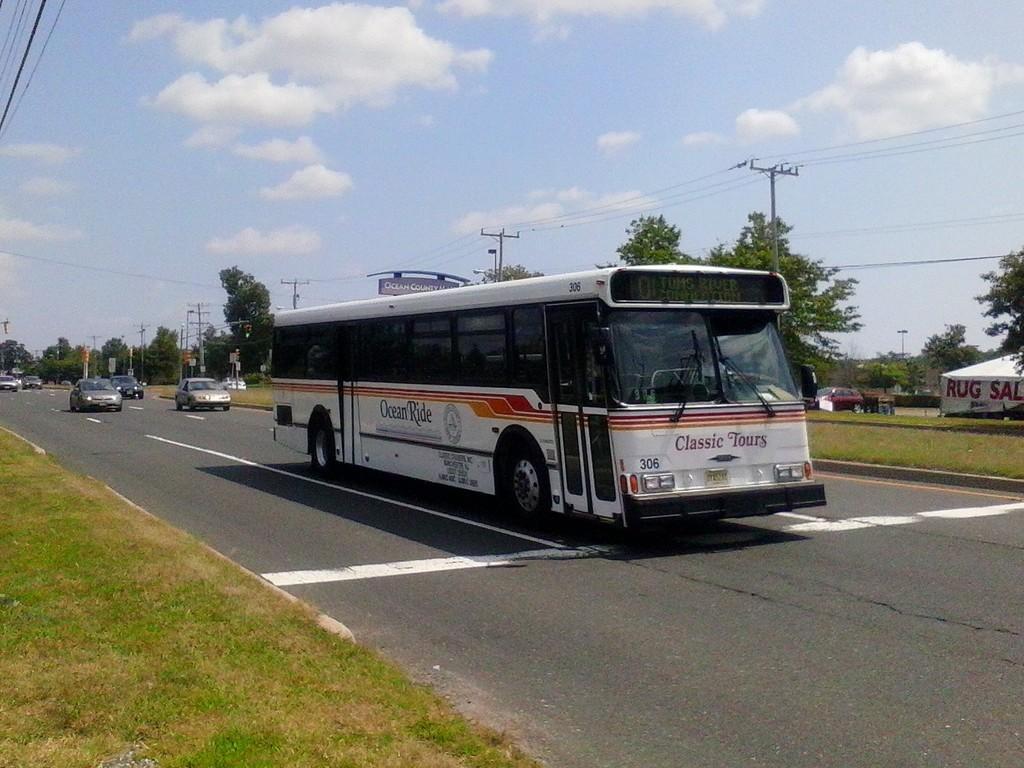In one or two sentences, can you explain what this image depicts? In this image I see the road on which there is a bus and I see few cars over here and I see the grass on either sides and in the background I see the trees, poles, wires, sky and I see a car over here and I see a banner over here on which there are words written. 